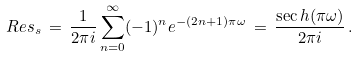<formula> <loc_0><loc_0><loc_500><loc_500>R e s _ { s } \, = \, \frac { 1 } { 2 \pi i } \sum _ { n = 0 } ^ { \infty } ( - 1 ) ^ { n } e ^ { - ( 2 n + 1 ) \pi \omega } \, = \, \frac { \sec h ( \pi \omega ) } { 2 \pi i } \, .</formula> 